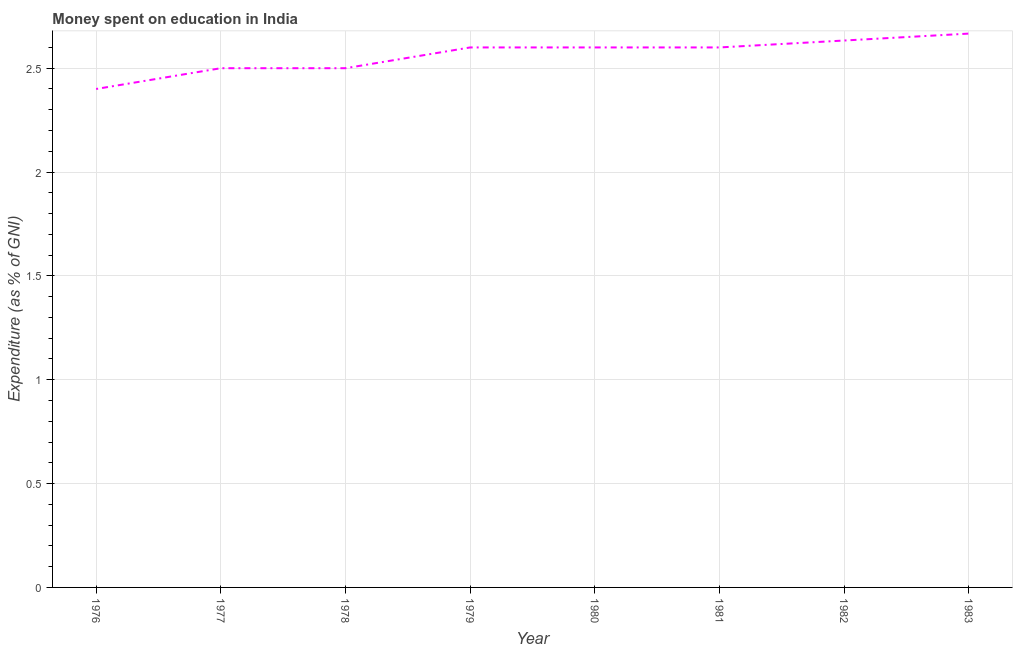Across all years, what is the maximum expenditure on education?
Your response must be concise. 2.67. Across all years, what is the minimum expenditure on education?
Offer a very short reply. 2.4. In which year was the expenditure on education maximum?
Provide a short and direct response. 1983. In which year was the expenditure on education minimum?
Provide a succinct answer. 1976. What is the sum of the expenditure on education?
Your answer should be very brief. 20.5. What is the difference between the expenditure on education in 1981 and 1983?
Give a very brief answer. -0.07. What is the average expenditure on education per year?
Your answer should be compact. 2.56. What is the median expenditure on education?
Provide a short and direct response. 2.6. In how many years, is the expenditure on education greater than 2.3 %?
Ensure brevity in your answer.  8. What is the ratio of the expenditure on education in 1978 to that in 1979?
Make the answer very short. 0.96. Is the difference between the expenditure on education in 1978 and 1981 greater than the difference between any two years?
Your response must be concise. No. What is the difference between the highest and the second highest expenditure on education?
Offer a very short reply. 0.03. What is the difference between the highest and the lowest expenditure on education?
Make the answer very short. 0.27. Does the expenditure on education monotonically increase over the years?
Provide a short and direct response. No. How many years are there in the graph?
Ensure brevity in your answer.  8. What is the difference between two consecutive major ticks on the Y-axis?
Your answer should be very brief. 0.5. Does the graph contain any zero values?
Your response must be concise. No. Does the graph contain grids?
Your answer should be compact. Yes. What is the title of the graph?
Provide a succinct answer. Money spent on education in India. What is the label or title of the Y-axis?
Keep it short and to the point. Expenditure (as % of GNI). What is the Expenditure (as % of GNI) in 1982?
Ensure brevity in your answer.  2.63. What is the Expenditure (as % of GNI) in 1983?
Give a very brief answer. 2.67. What is the difference between the Expenditure (as % of GNI) in 1976 and 1977?
Provide a short and direct response. -0.1. What is the difference between the Expenditure (as % of GNI) in 1976 and 1978?
Offer a very short reply. -0.1. What is the difference between the Expenditure (as % of GNI) in 1976 and 1979?
Ensure brevity in your answer.  -0.2. What is the difference between the Expenditure (as % of GNI) in 1976 and 1981?
Keep it short and to the point. -0.2. What is the difference between the Expenditure (as % of GNI) in 1976 and 1982?
Give a very brief answer. -0.23. What is the difference between the Expenditure (as % of GNI) in 1976 and 1983?
Offer a terse response. -0.27. What is the difference between the Expenditure (as % of GNI) in 1977 and 1978?
Offer a terse response. 0. What is the difference between the Expenditure (as % of GNI) in 1977 and 1979?
Give a very brief answer. -0.1. What is the difference between the Expenditure (as % of GNI) in 1977 and 1980?
Offer a very short reply. -0.1. What is the difference between the Expenditure (as % of GNI) in 1977 and 1981?
Offer a very short reply. -0.1. What is the difference between the Expenditure (as % of GNI) in 1977 and 1982?
Provide a succinct answer. -0.13. What is the difference between the Expenditure (as % of GNI) in 1977 and 1983?
Offer a terse response. -0.17. What is the difference between the Expenditure (as % of GNI) in 1978 and 1980?
Offer a terse response. -0.1. What is the difference between the Expenditure (as % of GNI) in 1978 and 1981?
Make the answer very short. -0.1. What is the difference between the Expenditure (as % of GNI) in 1978 and 1982?
Your answer should be very brief. -0.13. What is the difference between the Expenditure (as % of GNI) in 1978 and 1983?
Your answer should be compact. -0.17. What is the difference between the Expenditure (as % of GNI) in 1979 and 1980?
Your answer should be very brief. 0. What is the difference between the Expenditure (as % of GNI) in 1979 and 1982?
Offer a terse response. -0.03. What is the difference between the Expenditure (as % of GNI) in 1979 and 1983?
Keep it short and to the point. -0.07. What is the difference between the Expenditure (as % of GNI) in 1980 and 1982?
Offer a very short reply. -0.03. What is the difference between the Expenditure (as % of GNI) in 1980 and 1983?
Offer a very short reply. -0.07. What is the difference between the Expenditure (as % of GNI) in 1981 and 1982?
Your response must be concise. -0.03. What is the difference between the Expenditure (as % of GNI) in 1981 and 1983?
Ensure brevity in your answer.  -0.07. What is the difference between the Expenditure (as % of GNI) in 1982 and 1983?
Your response must be concise. -0.03. What is the ratio of the Expenditure (as % of GNI) in 1976 to that in 1979?
Keep it short and to the point. 0.92. What is the ratio of the Expenditure (as % of GNI) in 1976 to that in 1980?
Offer a terse response. 0.92. What is the ratio of the Expenditure (as % of GNI) in 1976 to that in 1981?
Provide a succinct answer. 0.92. What is the ratio of the Expenditure (as % of GNI) in 1976 to that in 1982?
Offer a terse response. 0.91. What is the ratio of the Expenditure (as % of GNI) in 1976 to that in 1983?
Your answer should be very brief. 0.9. What is the ratio of the Expenditure (as % of GNI) in 1977 to that in 1980?
Ensure brevity in your answer.  0.96. What is the ratio of the Expenditure (as % of GNI) in 1977 to that in 1982?
Your answer should be very brief. 0.95. What is the ratio of the Expenditure (as % of GNI) in 1977 to that in 1983?
Offer a very short reply. 0.94. What is the ratio of the Expenditure (as % of GNI) in 1978 to that in 1981?
Your answer should be compact. 0.96. What is the ratio of the Expenditure (as % of GNI) in 1978 to that in 1982?
Ensure brevity in your answer.  0.95. What is the ratio of the Expenditure (as % of GNI) in 1978 to that in 1983?
Ensure brevity in your answer.  0.94. What is the ratio of the Expenditure (as % of GNI) in 1980 to that in 1982?
Make the answer very short. 0.99. What is the ratio of the Expenditure (as % of GNI) in 1980 to that in 1983?
Your response must be concise. 0.97. What is the ratio of the Expenditure (as % of GNI) in 1981 to that in 1983?
Offer a terse response. 0.97. What is the ratio of the Expenditure (as % of GNI) in 1982 to that in 1983?
Give a very brief answer. 0.99. 